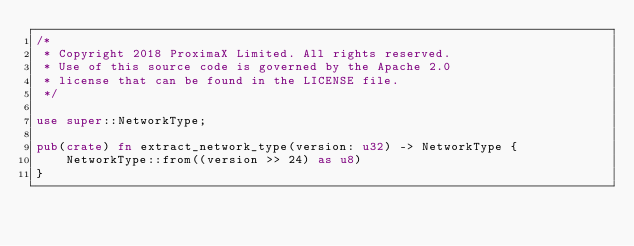<code> <loc_0><loc_0><loc_500><loc_500><_Rust_>/*
 * Copyright 2018 ProximaX Limited. All rights reserved.
 * Use of this source code is governed by the Apache 2.0
 * license that can be found in the LICENSE file.
 */

use super::NetworkType;

pub(crate) fn extract_network_type(version: u32) -> NetworkType {
    NetworkType::from((version >> 24) as u8)
}
</code> 